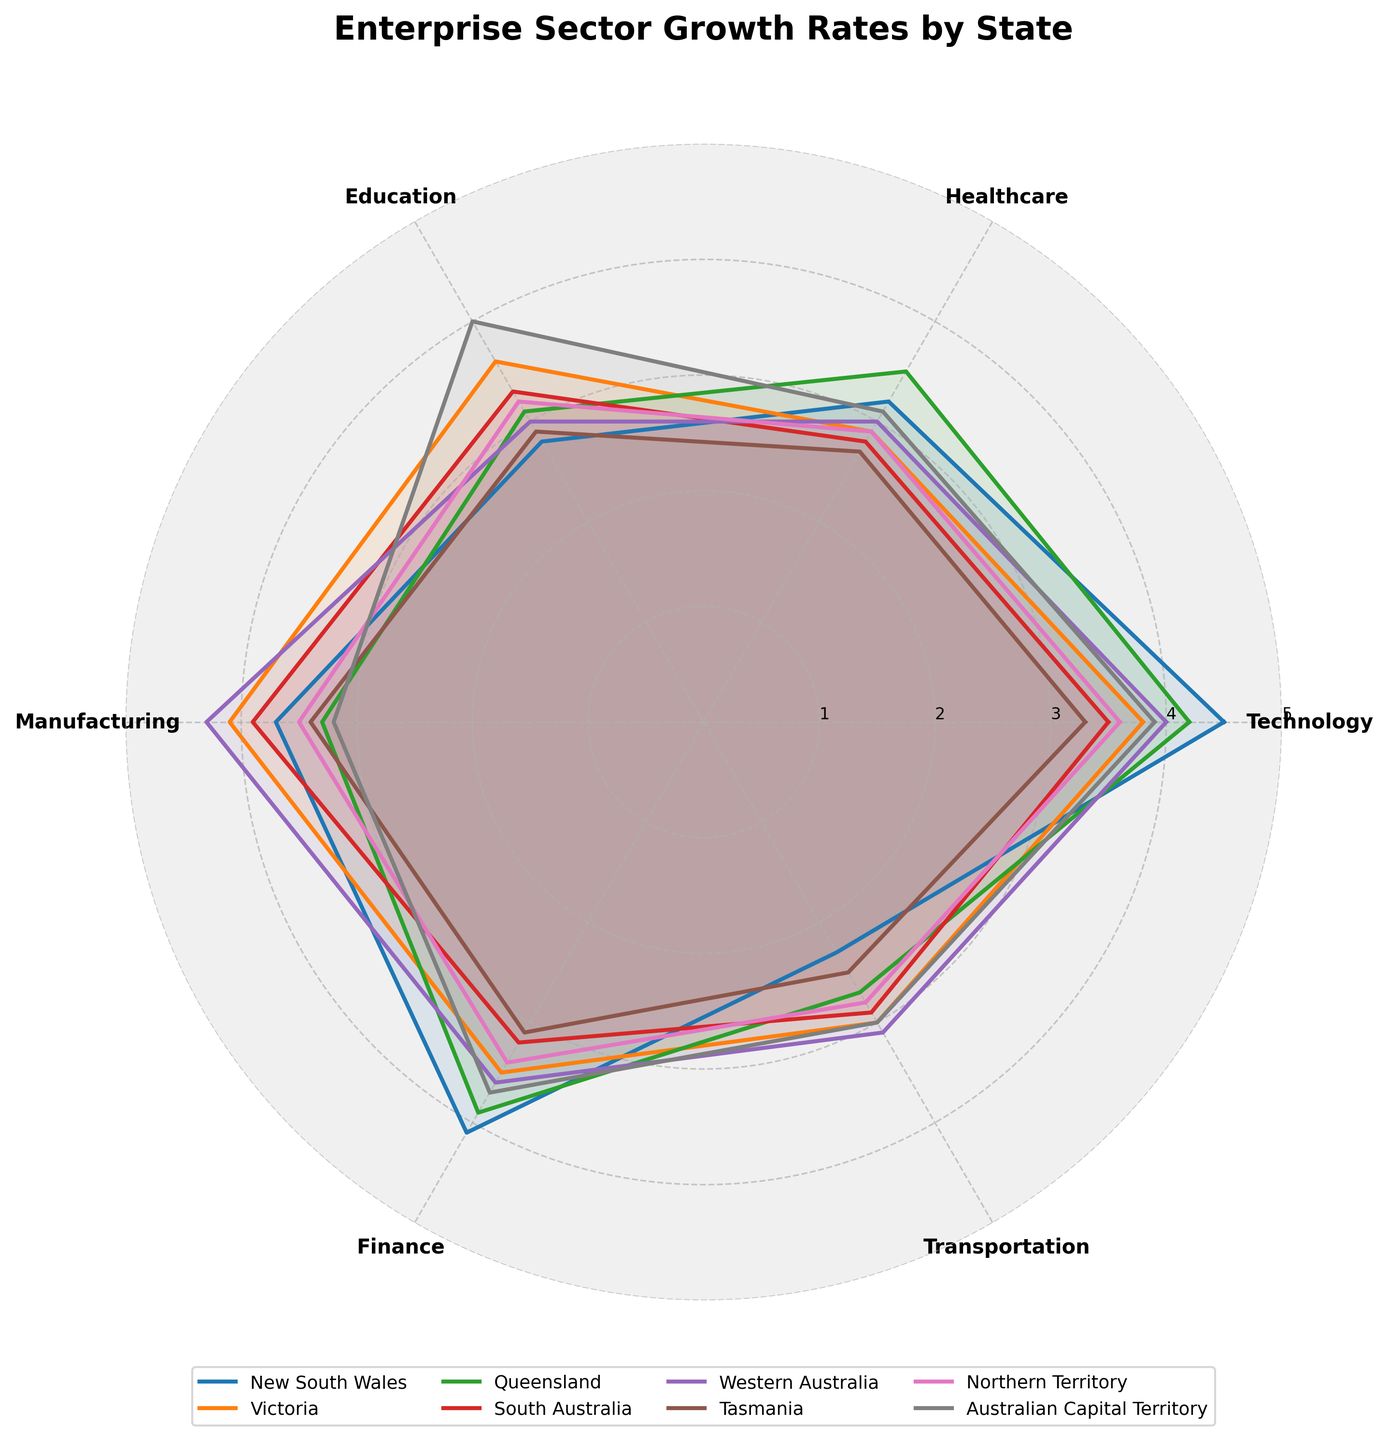What is the title of the chart? The title is usually placed at the top-middle of the chart. In this case, it reads "Enterprise Sector Growth Rates by State".
Answer: Enterprise Sector Growth Rates by State What are the sectors represented in the chart? The sectors are labeled around the polar chart. They are Technology, Healthcare, Education, Manufacturing, Finance, and Transportation.
Answer: Technology, Healthcare, Education, Manufacturing, Finance, Transportation Which state shows the highest growth rate in the Technology sector? Look at the point corresponding to the Technology sector for each state on the polar chart. New South Wales has a growth rate of 4.5, the highest value for the Technology sector.
Answer: New South Wales Which sector has the lowest growth rate for Queensland? Identify Queensland's plot line and check the values for each sector. Transportation has the lowest value at 2.7.
Answer: Transportation How does the growth rate of the Education sector in Victoria compare to the Australian Capital Territory? Compare the values of the Education sector for both states. Victoria has 3.6 and the Australian Capital Territory has 4.0, indicating that the growth rate is higher in the Australian Capital Territory.
Answer: Higher in Australian Capital Territory What is the average growth rate of the Finance sector across all states? Sum the Finance growth rates for all states (4.1 + 3.5 + 3.9 + 3.2 + 3.6 + 3.1 + 3.4 + 3.7) and divide by the number of states (8). The average is (28.5 / 8) = 3.56.
Answer: 3.56 Which state has the most consistent growth across all sectors? Check the plot lines for uniformity across all sectors for each state. Northern Territory and Australian Capital Territory both show relatively consistent values.
Answer: Northern Territory, Australian Capital Territory What is the difference in growth rate for the Manufacturing sector between Western Australia and South Australia? Subtract the Manufacturing growth rate of South Australia from Western Australia (4.3 - 3.9). The difference is 0.4.
Answer: 0.4 Which state has the highest growth rate in the Transportation sector? Identify the highest value in the Transportation sector for all states. Western Australia has the highest value at 3.1.
Answer: Western Australia How many sectors exhibit a growth rate higher than 3.0 for Tasmania? Count the number of sectors with values above 3.0 for Tasmania. Only Manufacturing (3.4) and Finance (3.1) are above 3.0.
Answer: 2 